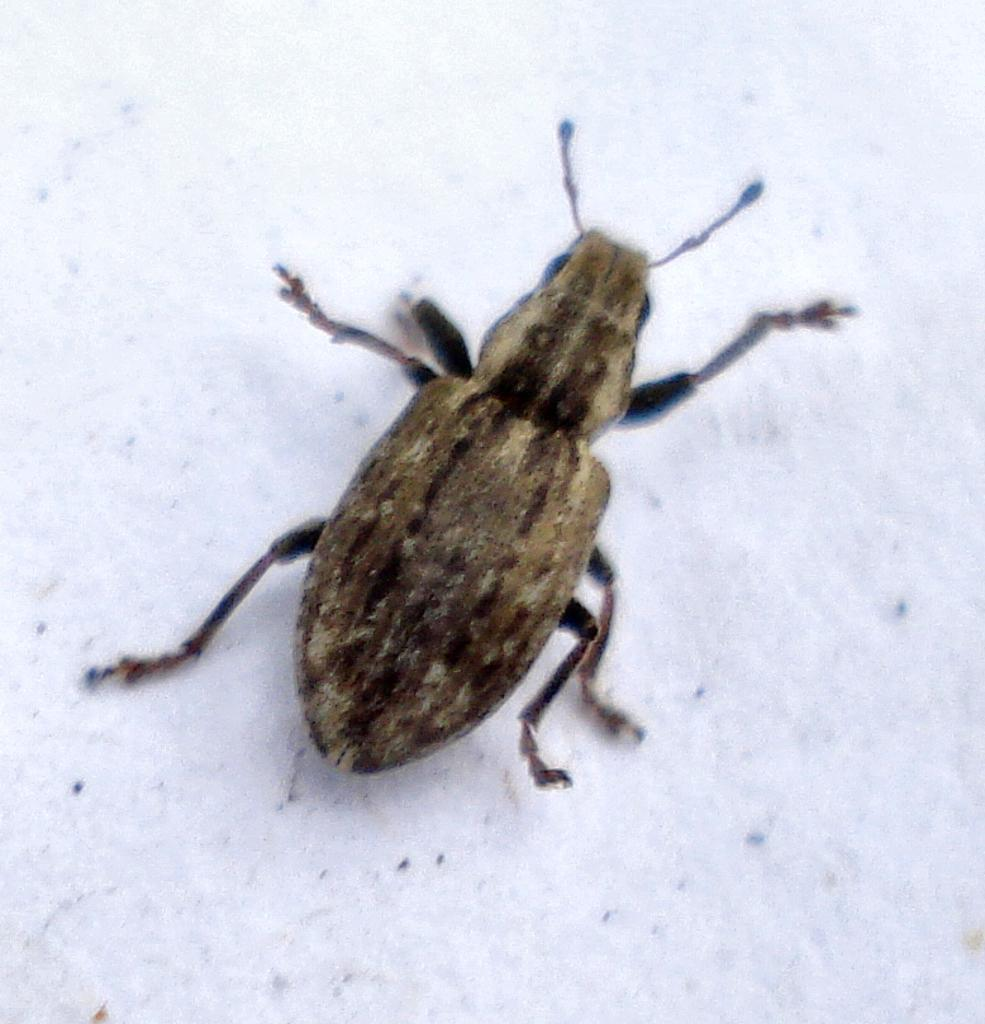What type of creature can be seen in the picture? There is an insect in the picture. What is the color of the floor at the bottom of the image? The floor at the bottom of the image is white. What advice does the mom give to the insect in the image? There is no mom present in the image, and therefore no advice can be given. 